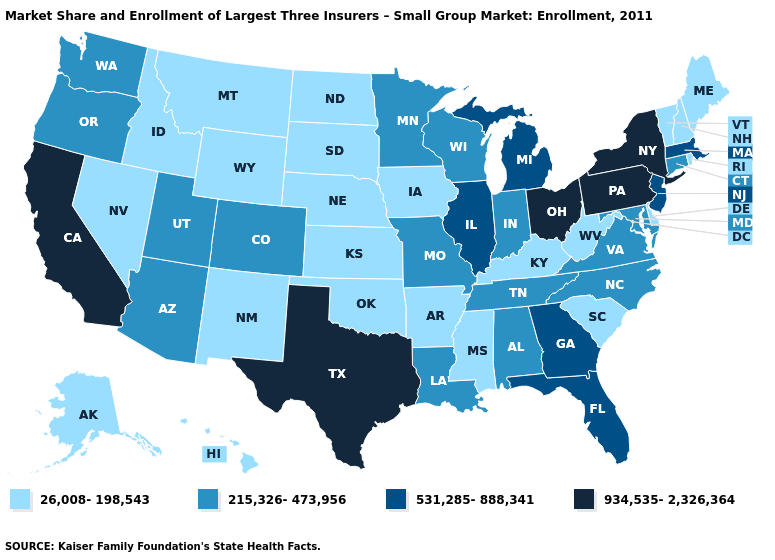Does Missouri have the same value as Maine?
Give a very brief answer. No. Name the states that have a value in the range 215,326-473,956?
Short answer required. Alabama, Arizona, Colorado, Connecticut, Indiana, Louisiana, Maryland, Minnesota, Missouri, North Carolina, Oregon, Tennessee, Utah, Virginia, Washington, Wisconsin. Is the legend a continuous bar?
Concise answer only. No. Does Indiana have the same value as North Carolina?
Keep it brief. Yes. What is the value of Texas?
Answer briefly. 934,535-2,326,364. What is the lowest value in the West?
Quick response, please. 26,008-198,543. What is the highest value in states that border Rhode Island?
Answer briefly. 531,285-888,341. Name the states that have a value in the range 934,535-2,326,364?
Give a very brief answer. California, New York, Ohio, Pennsylvania, Texas. Name the states that have a value in the range 26,008-198,543?
Quick response, please. Alaska, Arkansas, Delaware, Hawaii, Idaho, Iowa, Kansas, Kentucky, Maine, Mississippi, Montana, Nebraska, Nevada, New Hampshire, New Mexico, North Dakota, Oklahoma, Rhode Island, South Carolina, South Dakota, Vermont, West Virginia, Wyoming. What is the value of Maine?
Write a very short answer. 26,008-198,543. Does the first symbol in the legend represent the smallest category?
Be succinct. Yes. Does Utah have the lowest value in the USA?
Be succinct. No. Name the states that have a value in the range 215,326-473,956?
Quick response, please. Alabama, Arizona, Colorado, Connecticut, Indiana, Louisiana, Maryland, Minnesota, Missouri, North Carolina, Oregon, Tennessee, Utah, Virginia, Washington, Wisconsin. Does Indiana have the lowest value in the USA?
Concise answer only. No. Name the states that have a value in the range 215,326-473,956?
Give a very brief answer. Alabama, Arizona, Colorado, Connecticut, Indiana, Louisiana, Maryland, Minnesota, Missouri, North Carolina, Oregon, Tennessee, Utah, Virginia, Washington, Wisconsin. 